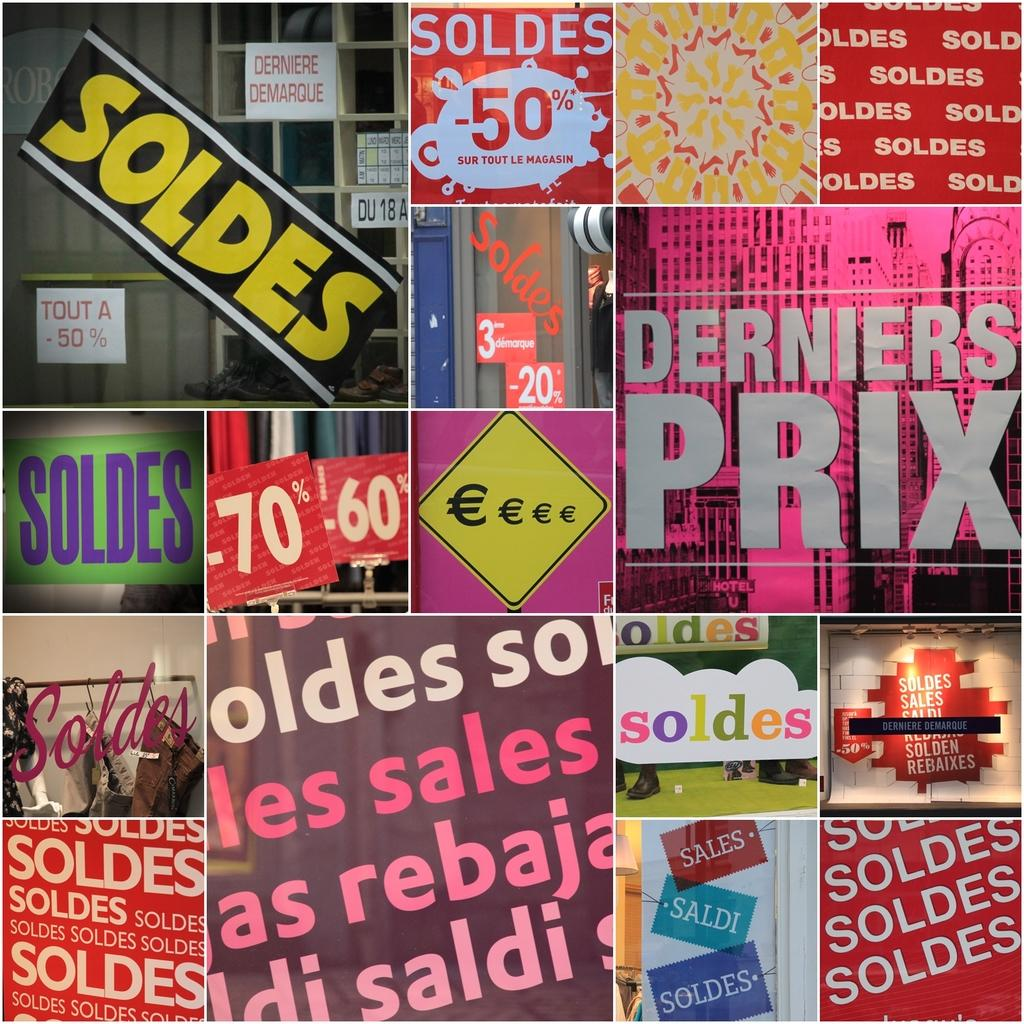<image>
Give a short and clear explanation of the subsequent image. a surface with derniers prix written on it 